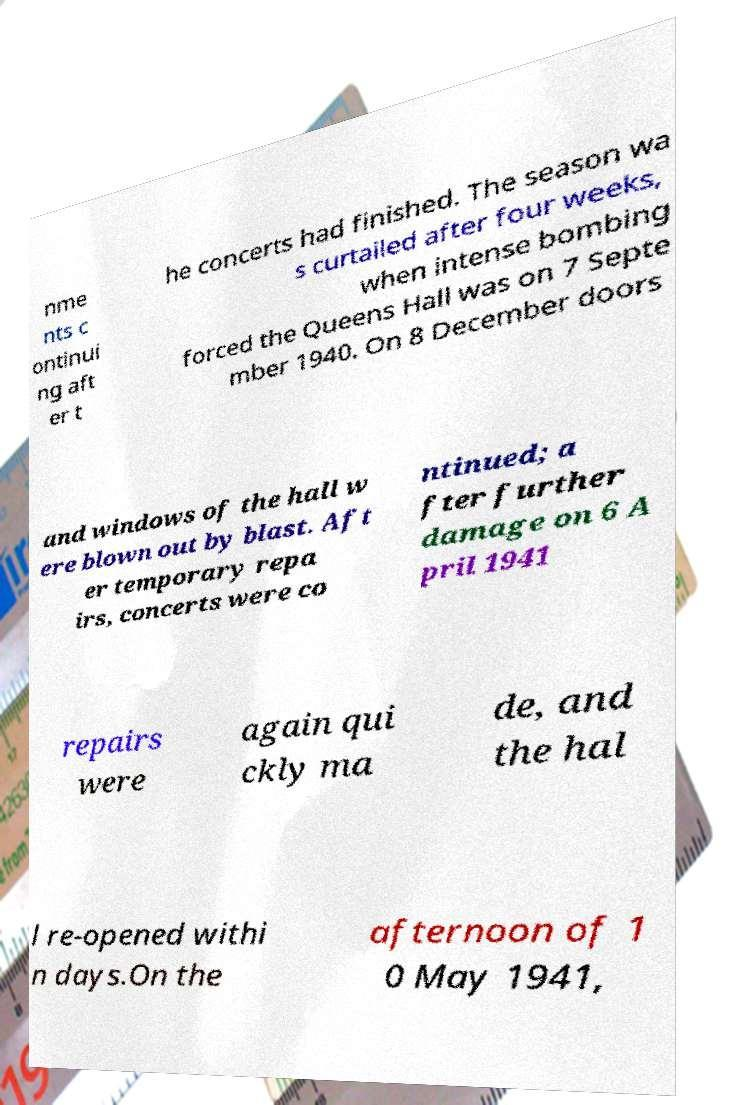For documentation purposes, I need the text within this image transcribed. Could you provide that? nme nts c ontinui ng aft er t he concerts had finished. The season wa s curtailed after four weeks, when intense bombing forced the Queens Hall was on 7 Septe mber 1940. On 8 December doors and windows of the hall w ere blown out by blast. Aft er temporary repa irs, concerts were co ntinued; a fter further damage on 6 A pril 1941 repairs were again qui ckly ma de, and the hal l re-opened withi n days.On the afternoon of 1 0 May 1941, 